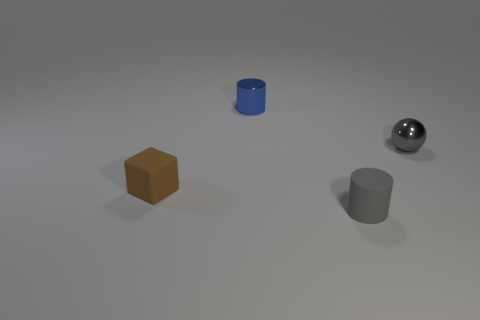Is there a gray sphere made of the same material as the tiny blue object?
Offer a very short reply. Yes. What is the shape of the object that is both on the right side of the matte cube and to the left of the tiny gray matte object?
Your answer should be very brief. Cylinder. What number of other objects are there of the same shape as the small gray rubber object?
Provide a succinct answer. 1. How many objects are yellow shiny objects or blocks?
Provide a succinct answer. 1. What is the color of the thing that is in front of the small blue cylinder and behind the matte cube?
Your answer should be compact. Gray. Is the ball to the right of the tiny blue thing made of the same material as the tiny blue thing?
Offer a very short reply. Yes. Is the color of the matte cylinder the same as the tiny metallic thing in front of the tiny blue cylinder?
Your answer should be compact. Yes. Are there any tiny blue metallic objects on the left side of the blue cylinder?
Offer a terse response. No. Is there a blue shiny thing that has the same size as the gray cylinder?
Provide a succinct answer. Yes. Does the small rubber thing right of the tiny blue cylinder have the same shape as the tiny blue metal object?
Make the answer very short. Yes. 